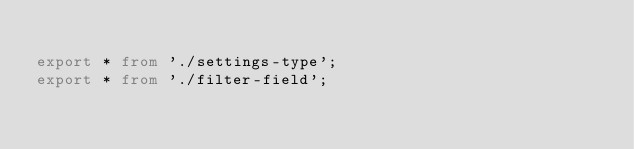Convert code to text. <code><loc_0><loc_0><loc_500><loc_500><_TypeScript_>
export * from './settings-type';
export * from './filter-field';
</code> 